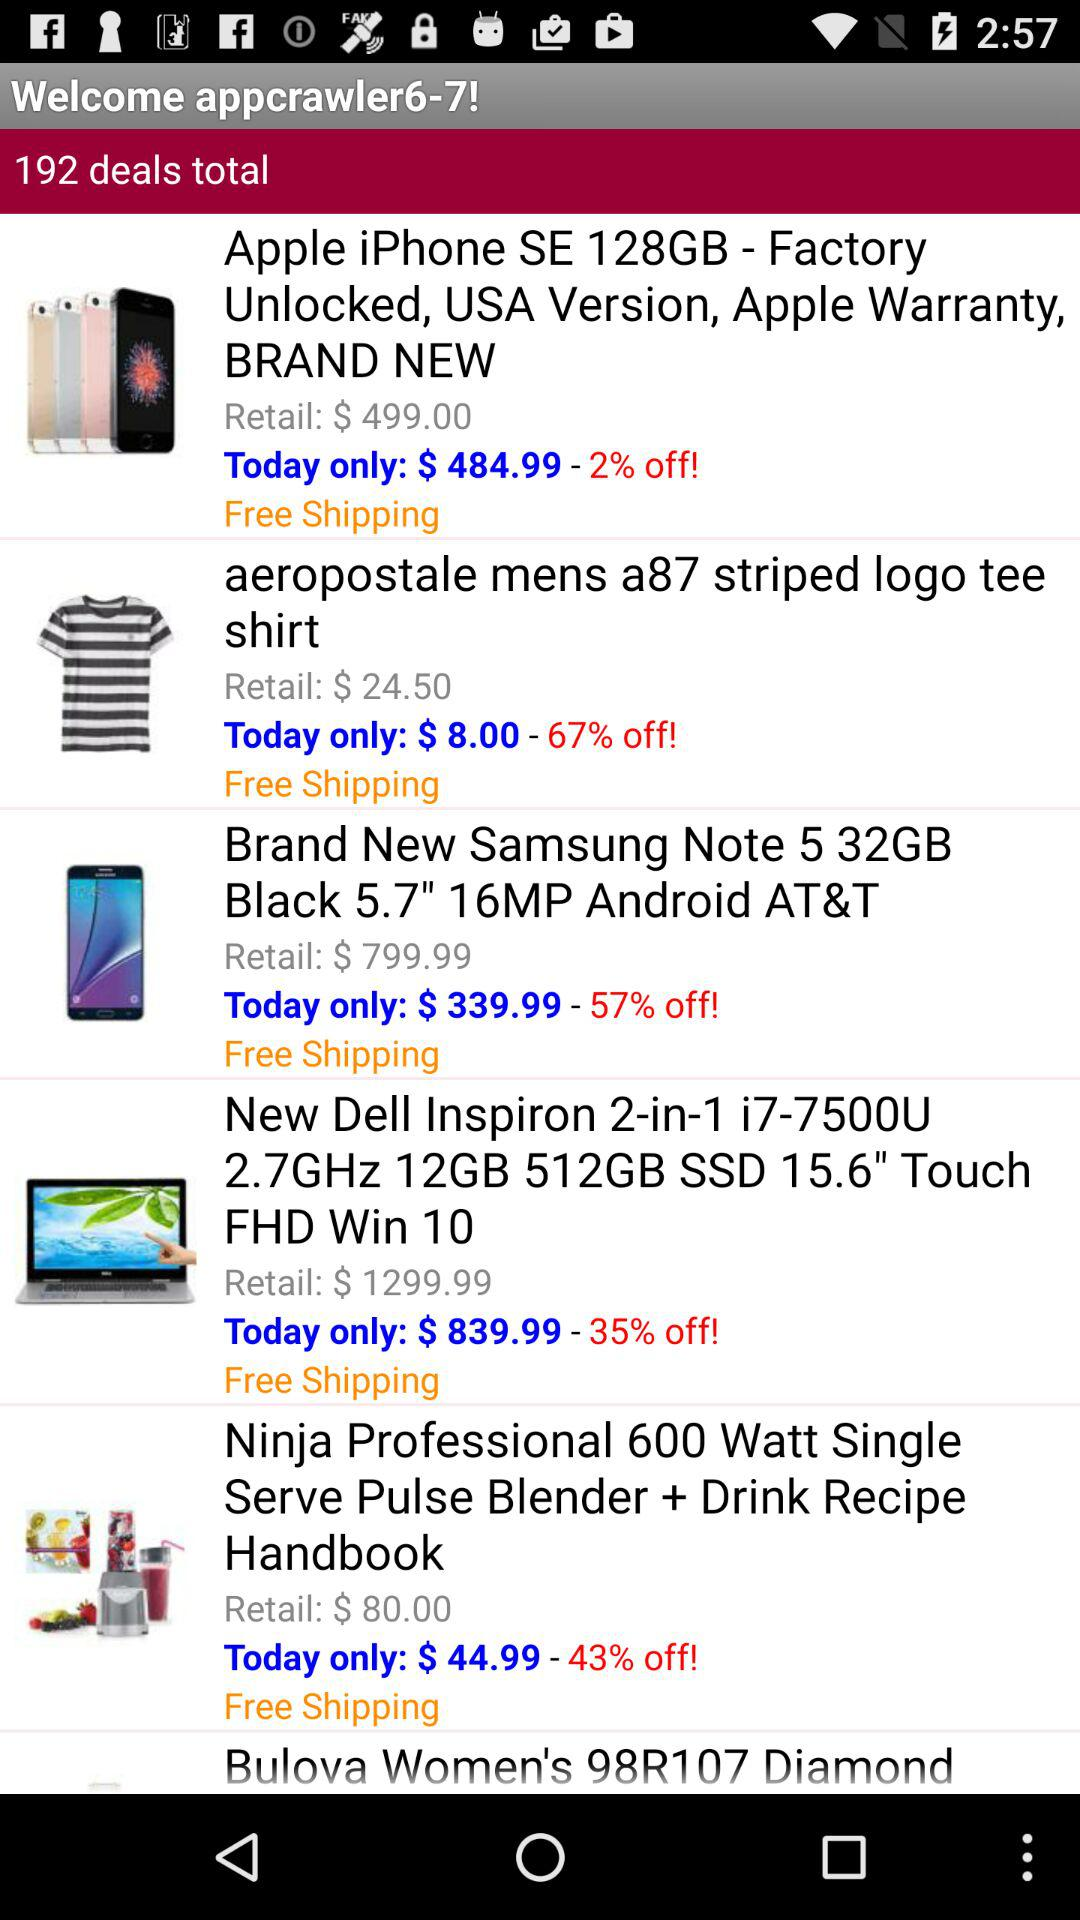What is the price of the "Samsung Note 5" for today? The price of the "Samsung Note 5" for today is $339.99. 